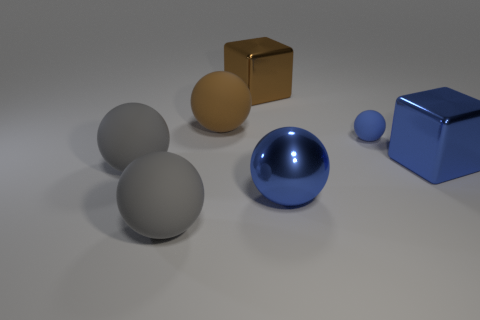Add 2 matte cylinders. How many objects exist? 9 Subtract all big balls. How many balls are left? 1 Subtract 2 spheres. How many spheres are left? 3 Subtract all spheres. How many objects are left? 2 Subtract all blue blocks. How many blocks are left? 1 Subtract 0 gray blocks. How many objects are left? 7 Subtract all gray balls. Subtract all red cylinders. How many balls are left? 3 Subtract all cyan spheres. How many brown cubes are left? 1 Subtract all tiny brown metallic cylinders. Subtract all gray things. How many objects are left? 5 Add 7 brown objects. How many brown objects are left? 9 